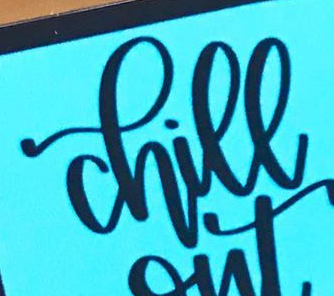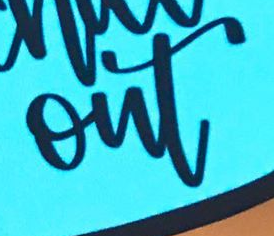Read the text content from these images in order, separated by a semicolon. chill; out 